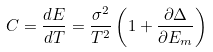Convert formula to latex. <formula><loc_0><loc_0><loc_500><loc_500>C = \frac { d E } { d T } = \frac { \sigma ^ { 2 } } { T ^ { 2 } } \left ( 1 + \frac { \partial \Delta } { \partial E _ { m } } \right )</formula> 